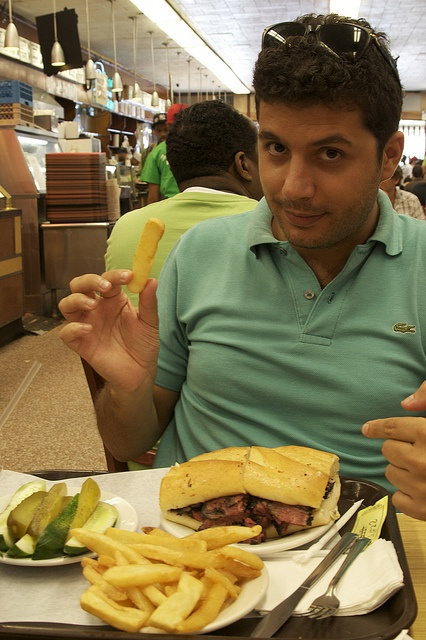Describe the objects in this image and their specific colors. I can see people in gray, darkgreen, black, and maroon tones, dining table in gray, tan, orange, and black tones, sandwich in gray, gold, orange, and maroon tones, people in gray, black, khaki, and maroon tones, and knife in gray, olive, beige, and tan tones in this image. 